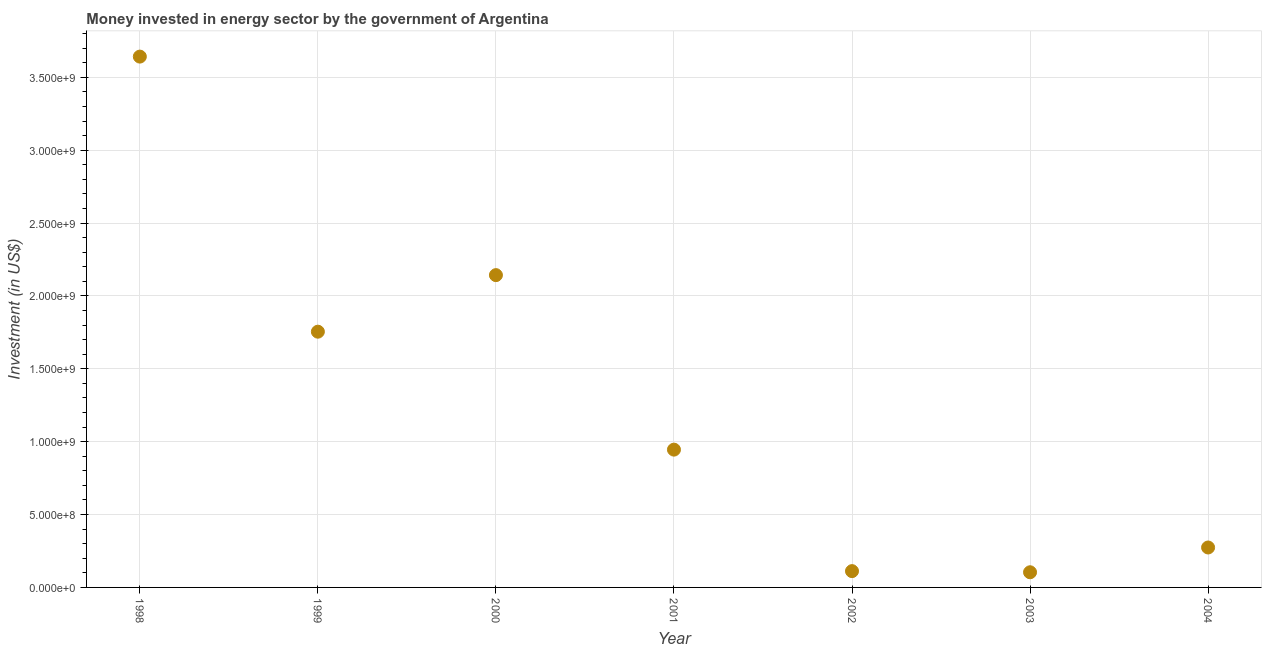What is the investment in energy in 2004?
Keep it short and to the point. 2.74e+08. Across all years, what is the maximum investment in energy?
Your answer should be very brief. 3.64e+09. Across all years, what is the minimum investment in energy?
Offer a very short reply. 1.04e+08. In which year was the investment in energy maximum?
Ensure brevity in your answer.  1998. What is the sum of the investment in energy?
Your answer should be compact. 8.98e+09. What is the difference between the investment in energy in 2001 and 2002?
Offer a very short reply. 8.34e+08. What is the average investment in energy per year?
Provide a short and direct response. 1.28e+09. What is the median investment in energy?
Provide a succinct answer. 9.46e+08. What is the ratio of the investment in energy in 2002 to that in 2003?
Offer a very short reply. 1.07. What is the difference between the highest and the second highest investment in energy?
Offer a terse response. 1.50e+09. What is the difference between the highest and the lowest investment in energy?
Your response must be concise. 3.54e+09. Does the investment in energy monotonically increase over the years?
Make the answer very short. No. How many dotlines are there?
Keep it short and to the point. 1. What is the difference between two consecutive major ticks on the Y-axis?
Your answer should be compact. 5.00e+08. Are the values on the major ticks of Y-axis written in scientific E-notation?
Your answer should be compact. Yes. Does the graph contain any zero values?
Your response must be concise. No. What is the title of the graph?
Your answer should be very brief. Money invested in energy sector by the government of Argentina. What is the label or title of the Y-axis?
Offer a very short reply. Investment (in US$). What is the Investment (in US$) in 1998?
Your answer should be very brief. 3.64e+09. What is the Investment (in US$) in 1999?
Provide a succinct answer. 1.75e+09. What is the Investment (in US$) in 2000?
Provide a short and direct response. 2.14e+09. What is the Investment (in US$) in 2001?
Ensure brevity in your answer.  9.46e+08. What is the Investment (in US$) in 2002?
Provide a short and direct response. 1.12e+08. What is the Investment (in US$) in 2003?
Your response must be concise. 1.04e+08. What is the Investment (in US$) in 2004?
Ensure brevity in your answer.  2.74e+08. What is the difference between the Investment (in US$) in 1998 and 1999?
Provide a succinct answer. 1.89e+09. What is the difference between the Investment (in US$) in 1998 and 2000?
Ensure brevity in your answer.  1.50e+09. What is the difference between the Investment (in US$) in 1998 and 2001?
Give a very brief answer. 2.70e+09. What is the difference between the Investment (in US$) in 1998 and 2002?
Your answer should be very brief. 3.53e+09. What is the difference between the Investment (in US$) in 1998 and 2003?
Your answer should be compact. 3.54e+09. What is the difference between the Investment (in US$) in 1998 and 2004?
Provide a short and direct response. 3.37e+09. What is the difference between the Investment (in US$) in 1999 and 2000?
Your answer should be very brief. -3.88e+08. What is the difference between the Investment (in US$) in 1999 and 2001?
Make the answer very short. 8.09e+08. What is the difference between the Investment (in US$) in 1999 and 2002?
Your answer should be compact. 1.64e+09. What is the difference between the Investment (in US$) in 1999 and 2003?
Make the answer very short. 1.65e+09. What is the difference between the Investment (in US$) in 1999 and 2004?
Offer a terse response. 1.48e+09. What is the difference between the Investment (in US$) in 2000 and 2001?
Make the answer very short. 1.20e+09. What is the difference between the Investment (in US$) in 2000 and 2002?
Your answer should be very brief. 2.03e+09. What is the difference between the Investment (in US$) in 2000 and 2003?
Make the answer very short. 2.04e+09. What is the difference between the Investment (in US$) in 2000 and 2004?
Provide a short and direct response. 1.87e+09. What is the difference between the Investment (in US$) in 2001 and 2002?
Provide a short and direct response. 8.34e+08. What is the difference between the Investment (in US$) in 2001 and 2003?
Provide a short and direct response. 8.41e+08. What is the difference between the Investment (in US$) in 2001 and 2004?
Make the answer very short. 6.72e+08. What is the difference between the Investment (in US$) in 2002 and 2003?
Offer a terse response. 7.79e+06. What is the difference between the Investment (in US$) in 2002 and 2004?
Provide a short and direct response. -1.62e+08. What is the difference between the Investment (in US$) in 2003 and 2004?
Ensure brevity in your answer.  -1.70e+08. What is the ratio of the Investment (in US$) in 1998 to that in 1999?
Provide a succinct answer. 2.08. What is the ratio of the Investment (in US$) in 1998 to that in 2000?
Offer a terse response. 1.7. What is the ratio of the Investment (in US$) in 1998 to that in 2001?
Your response must be concise. 3.85. What is the ratio of the Investment (in US$) in 1998 to that in 2002?
Your answer should be compact. 32.57. What is the ratio of the Investment (in US$) in 1998 to that in 2003?
Make the answer very short. 35.01. What is the ratio of the Investment (in US$) in 1998 to that in 2004?
Make the answer very short. 13.29. What is the ratio of the Investment (in US$) in 1999 to that in 2000?
Keep it short and to the point. 0.82. What is the ratio of the Investment (in US$) in 1999 to that in 2001?
Your answer should be very brief. 1.86. What is the ratio of the Investment (in US$) in 1999 to that in 2002?
Provide a short and direct response. 15.69. What is the ratio of the Investment (in US$) in 1999 to that in 2003?
Keep it short and to the point. 16.87. What is the ratio of the Investment (in US$) in 1999 to that in 2004?
Give a very brief answer. 6.4. What is the ratio of the Investment (in US$) in 2000 to that in 2001?
Your answer should be compact. 2.27. What is the ratio of the Investment (in US$) in 2000 to that in 2002?
Ensure brevity in your answer.  19.16. What is the ratio of the Investment (in US$) in 2000 to that in 2003?
Offer a terse response. 20.6. What is the ratio of the Investment (in US$) in 2000 to that in 2004?
Provide a succinct answer. 7.82. What is the ratio of the Investment (in US$) in 2001 to that in 2002?
Make the answer very short. 8.46. What is the ratio of the Investment (in US$) in 2001 to that in 2003?
Make the answer very short. 9.09. What is the ratio of the Investment (in US$) in 2001 to that in 2004?
Provide a short and direct response. 3.45. What is the ratio of the Investment (in US$) in 2002 to that in 2003?
Your answer should be compact. 1.07. What is the ratio of the Investment (in US$) in 2002 to that in 2004?
Make the answer very short. 0.41. What is the ratio of the Investment (in US$) in 2003 to that in 2004?
Keep it short and to the point. 0.38. 